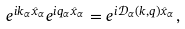<formula> <loc_0><loc_0><loc_500><loc_500>e ^ { i k _ { \alpha } { \hat { x } } _ { \alpha } } e ^ { i q _ { \alpha } { \hat { x } } _ { \alpha } } = e ^ { i { \mathcal { D } } _ { \alpha } ( k , q ) { \hat { x } } _ { \alpha } } ,</formula> 